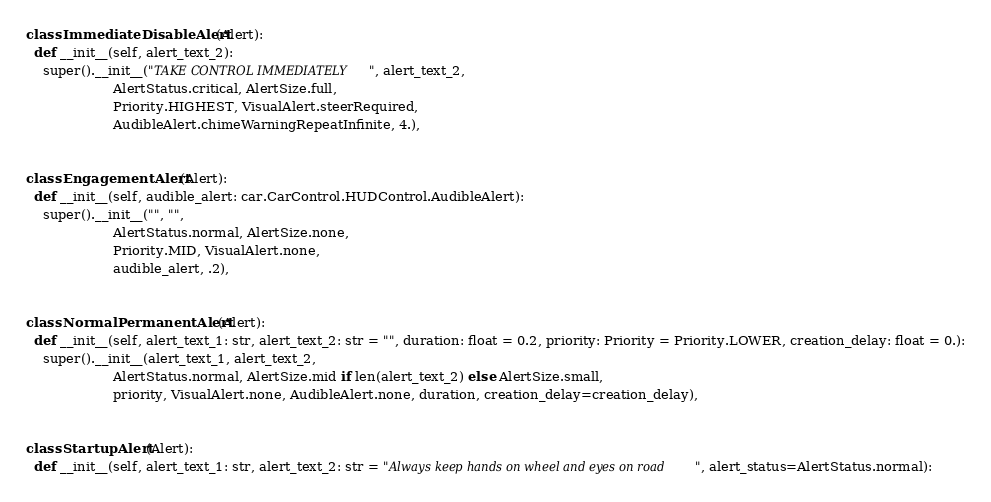Convert code to text. <code><loc_0><loc_0><loc_500><loc_500><_Python_>

class ImmediateDisableAlert(Alert):
  def __init__(self, alert_text_2):
    super().__init__("TAKE CONTROL IMMEDIATELY", alert_text_2,
                     AlertStatus.critical, AlertSize.full,
                     Priority.HIGHEST, VisualAlert.steerRequired,
                     AudibleAlert.chimeWarningRepeatInfinite, 4.),


class EngagementAlert(Alert):
  def __init__(self, audible_alert: car.CarControl.HUDControl.AudibleAlert):
    super().__init__("", "",
                     AlertStatus.normal, AlertSize.none,
                     Priority.MID, VisualAlert.none,
                     audible_alert, .2),


class NormalPermanentAlert(Alert):
  def __init__(self, alert_text_1: str, alert_text_2: str = "", duration: float = 0.2, priority: Priority = Priority.LOWER, creation_delay: float = 0.):
    super().__init__(alert_text_1, alert_text_2,
                     AlertStatus.normal, AlertSize.mid if len(alert_text_2) else AlertSize.small,
                     priority, VisualAlert.none, AudibleAlert.none, duration, creation_delay=creation_delay),


class StartupAlert(Alert):
  def __init__(self, alert_text_1: str, alert_text_2: str = "Always keep hands on wheel and eyes on road", alert_status=AlertStatus.normal):</code> 